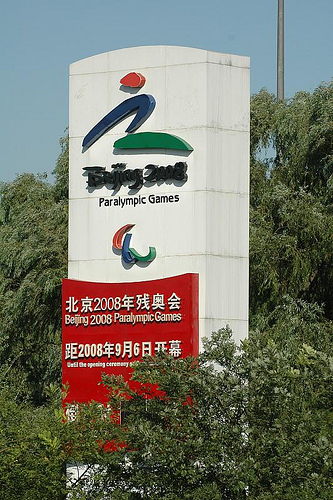<image>
Is there a wall behind the tree? No. The wall is not behind the tree. From this viewpoint, the wall appears to be positioned elsewhere in the scene. 